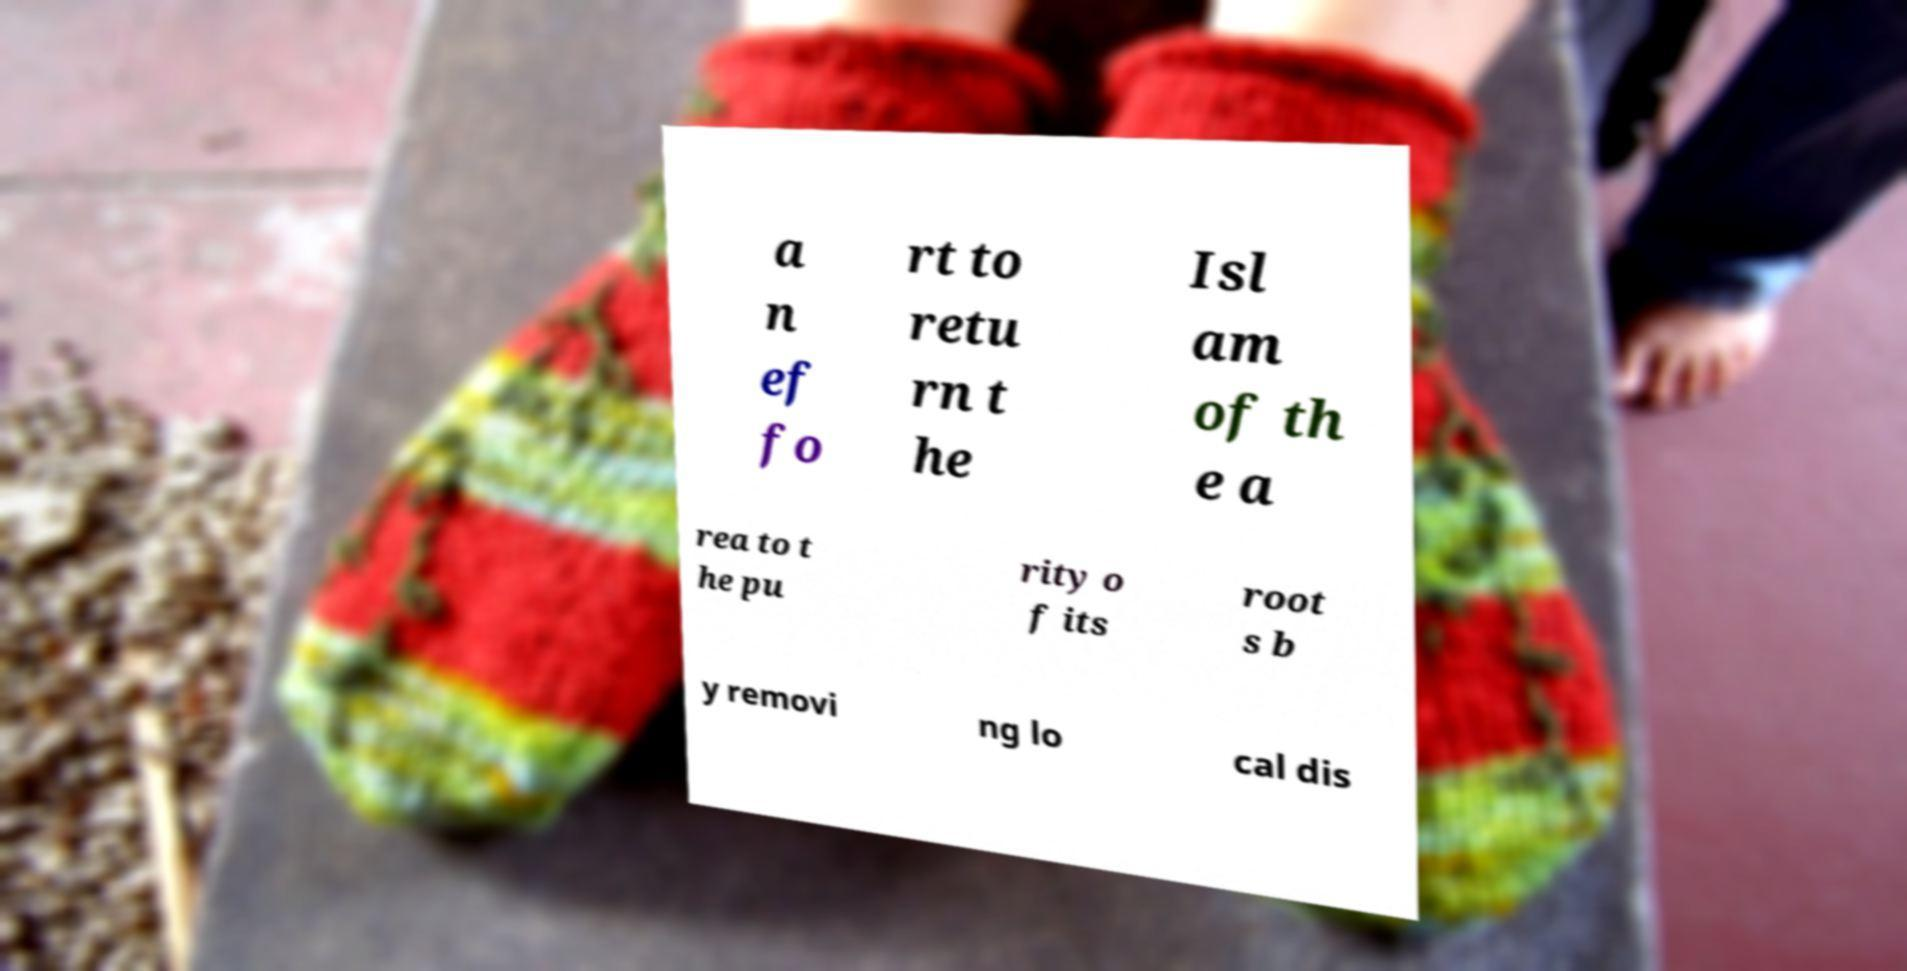Can you read and provide the text displayed in the image?This photo seems to have some interesting text. Can you extract and type it out for me? a n ef fo rt to retu rn t he Isl am of th e a rea to t he pu rity o f its root s b y removi ng lo cal dis 